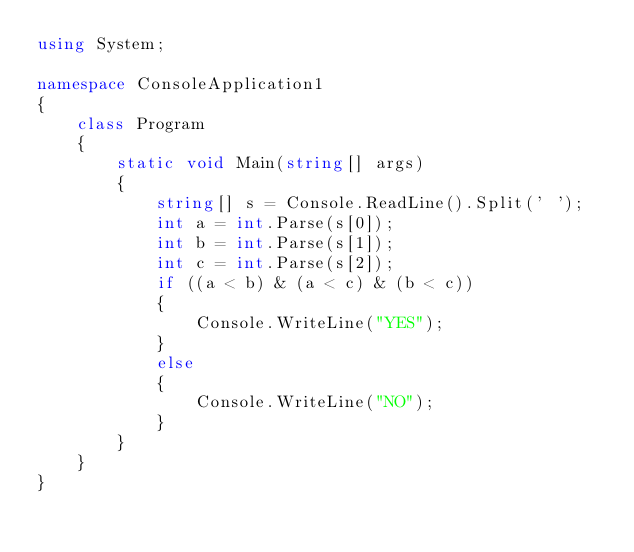Convert code to text. <code><loc_0><loc_0><loc_500><loc_500><_C#_>using System;

namespace ConsoleApplication1
{
    class Program
    {
        static void Main(string[] args)
        {
            string[] s = Console.ReadLine().Split(' ');
            int a = int.Parse(s[0]);
            int b = int.Parse(s[1]);
            int c = int.Parse(s[2]);
            if ((a < b) & (a < c) & (b < c))
            {
                Console.WriteLine("YES");
            }
            else
            {
                Console.WriteLine("NO");
            }
        }
    }
}</code> 